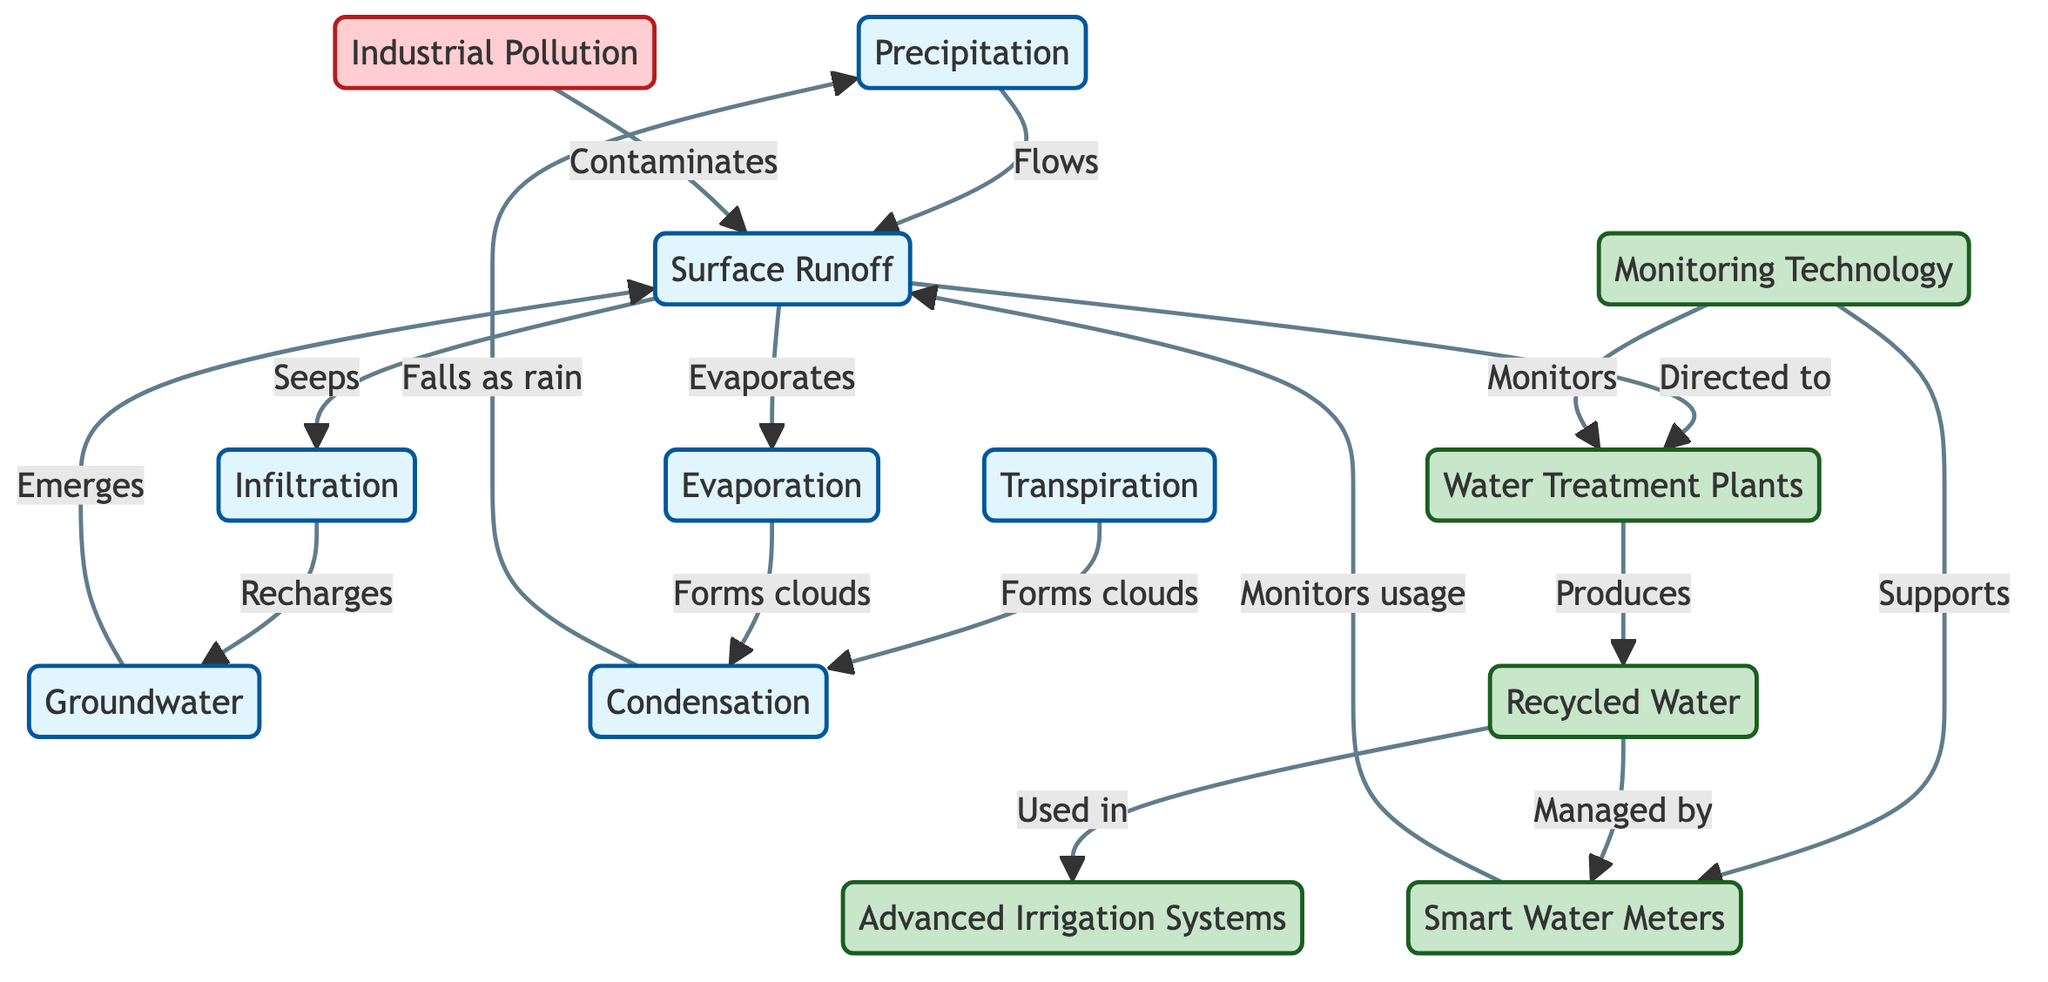What are the natural processes shown in the diagram? The diagram highlights several natural processes including Precipitation, Surface Runoff, Infiltration, Groundwater, Evaporation, Transpiration, and Condensation. Each of these nodes is marked with a specific color indicating they are natural processes.
Answer: Precipitation, Surface Runoff, Infiltration, Groundwater, Evaporation, Transpiration, Condensation How many technology solutions are presented in the diagram? The diagram features five technology solutions: Water Treatment Plants, Recycled Water, Monitoring Technology, Advanced Irrigation Systems, and Smart Water Meters. By counting the tech solution nodes, we see that there are five of them.
Answer: 5 What flows from Surface Runoff to Water Treatment Plants? According to the diagram, Surface Runoff is directed to Water Treatment Plants. The flow is indicated by a directed edge between the two nodes in the diagram.
Answer: Surface Runoff Which process falls as rain after condensation? The diagram indicates that precipitation falls as rain after condensation forms from evaporation and transpiration. Following the flow from the condensation node leads to the precipitation node where it states it falls as rain.
Answer: Precipitation What is used in Advanced Irrigation Systems? The flow from Recycled Water shows that it is used in Advanced Irrigation Systems. The arrow connecting these two nodes indicates that Recycled Water is applied in this context.
Answer: Recycled Water How is the water usage monitored in the diagram? The diagram mentions Smart Water Meters, which are supported by Monitoring Technology to monitor water usage. This indicates a direct relationship between monitoring technology and the smart meters node.
Answer: Smart Water Meters What contaminates Surface Runoff? The diagram illustrates that Industrial Pollution contaminates Surface Runoff, as indicated by the flow direction from the industrial pollution node to the surface runoff node.
Answer: Industrial Pollution What types of technology are utilized for monitoring water treatment plants? The diagram specifies that Monitoring Technology is responsible for monitoring Water Treatment Plants, illustrating the relationship where monitoring technology directly supports management of water treatment processes.
Answer: Monitoring Technology 